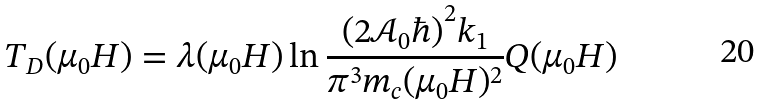Convert formula to latex. <formula><loc_0><loc_0><loc_500><loc_500>T _ { D } ( \mu _ { 0 } H ) = \lambda ( \mu _ { 0 } H ) \ln { \frac { ( 2 \mathcal { A } _ { 0 } \hbar { ) } ^ { 2 } k _ { 1 } } { \pi ^ { 3 } m _ { c } ( \mu _ { 0 } H ) ^ { 2 } } Q ( \mu _ { 0 } H ) } \\</formula> 